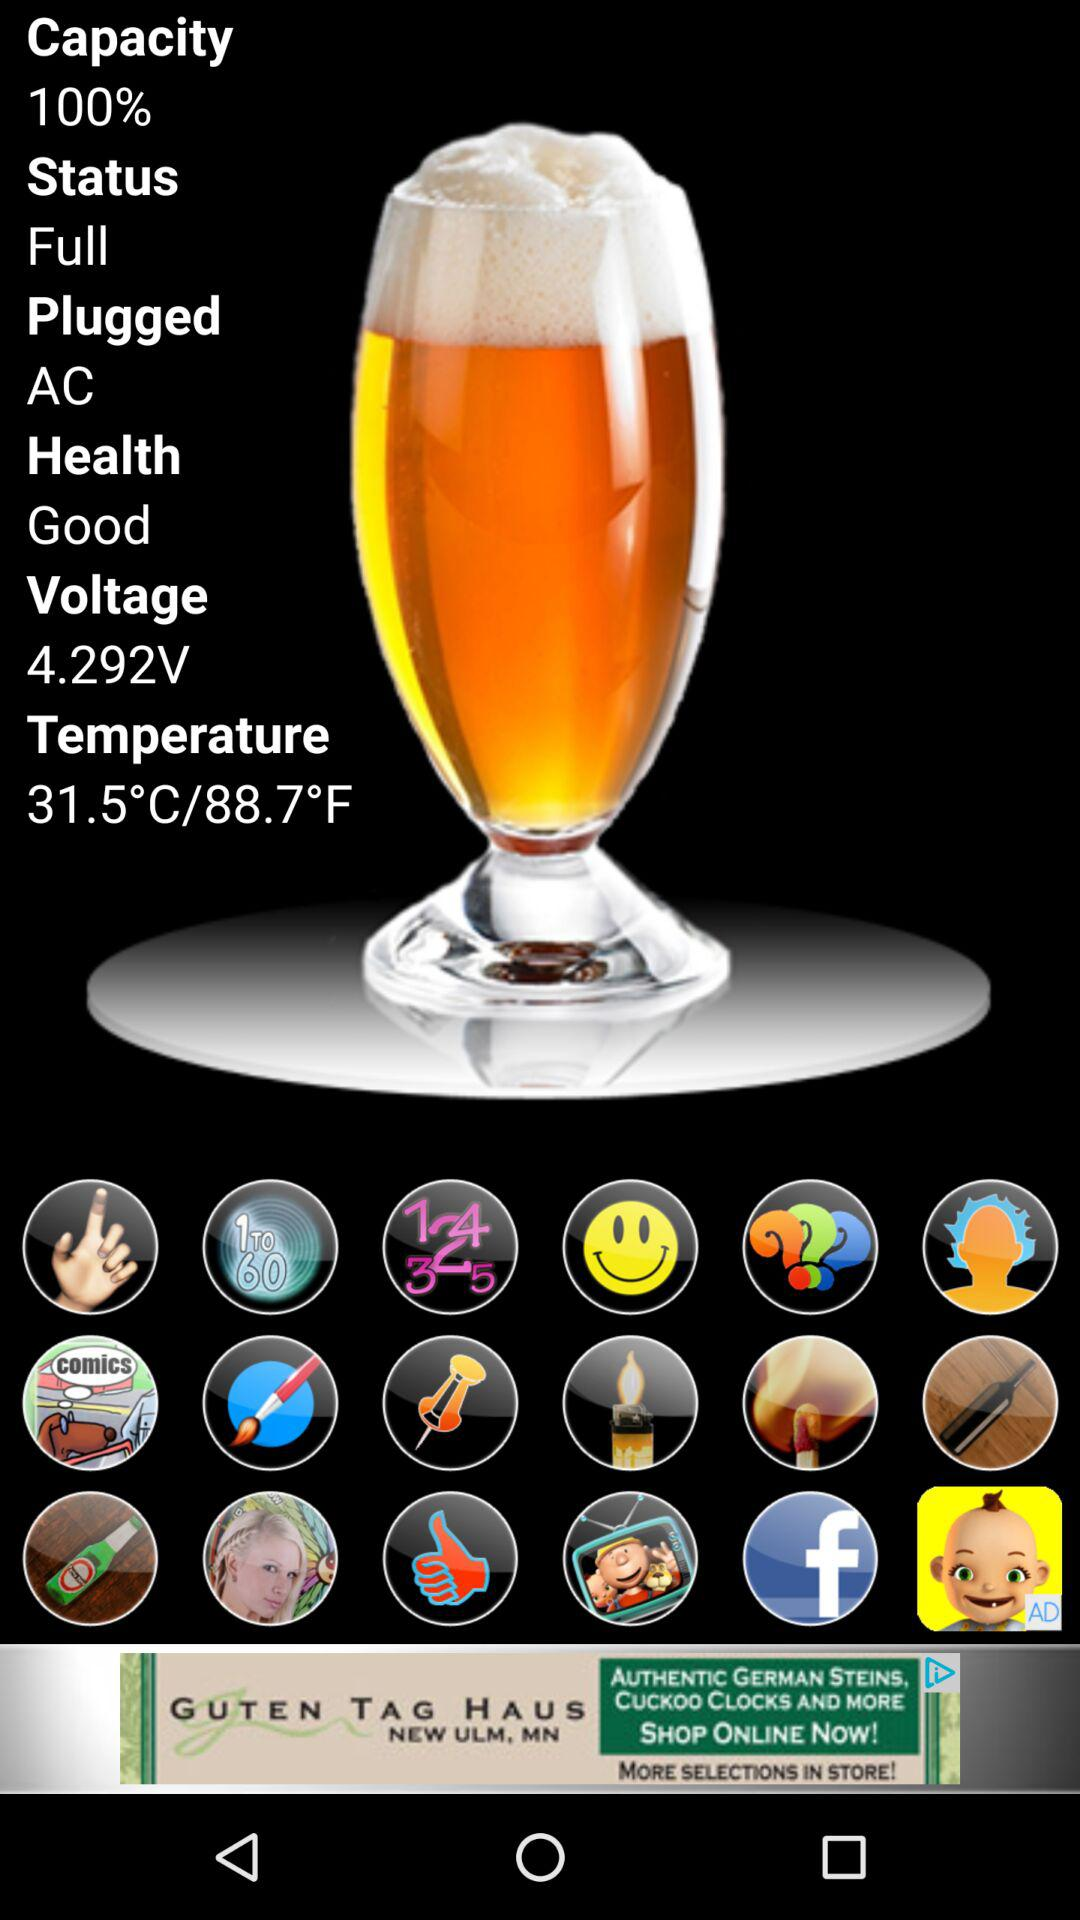What is the temperature? The temperature is 31.5 °C/88.7 °F. 